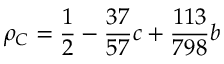Convert formula to latex. <formula><loc_0><loc_0><loc_500><loc_500>\rho _ { C } = \frac { 1 } { 2 } - \frac { 3 7 } { 5 7 } c + \frac { 1 1 3 } { 7 9 8 } b</formula> 